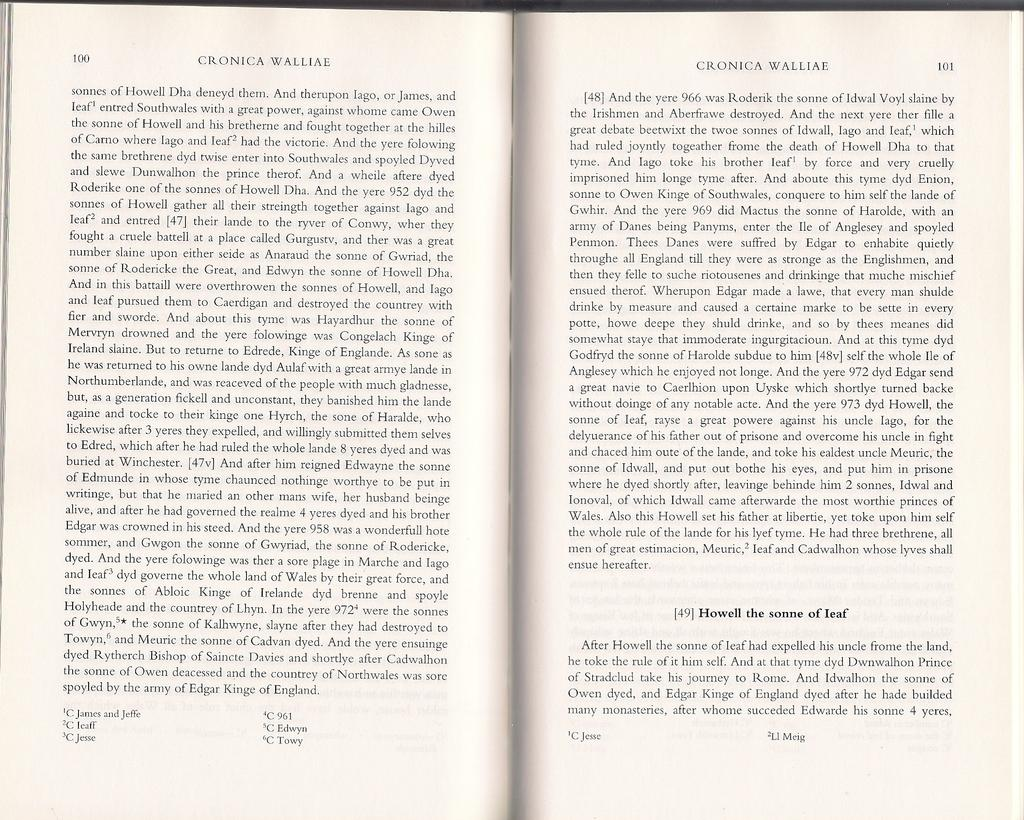<image>
Provide a brief description of the given image. A book open to pages 100 and 101 with the title Cronica Wolliae on top. 